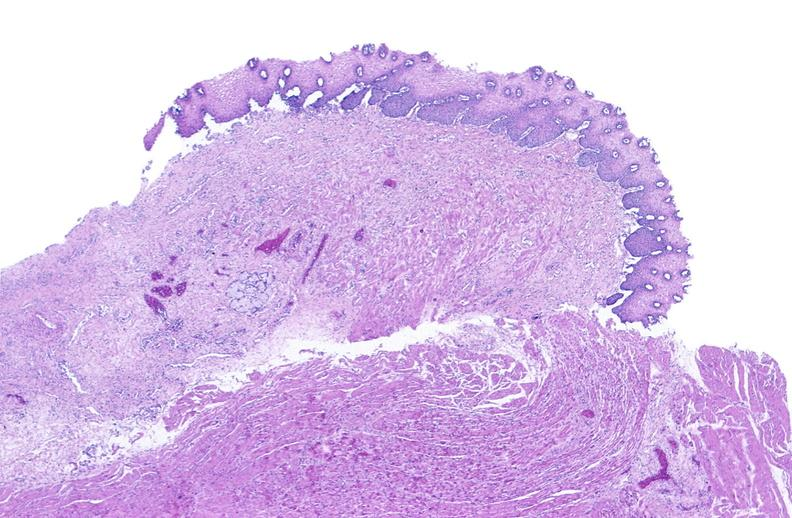does this image show esophagus?
Answer the question using a single word or phrase. Yes 